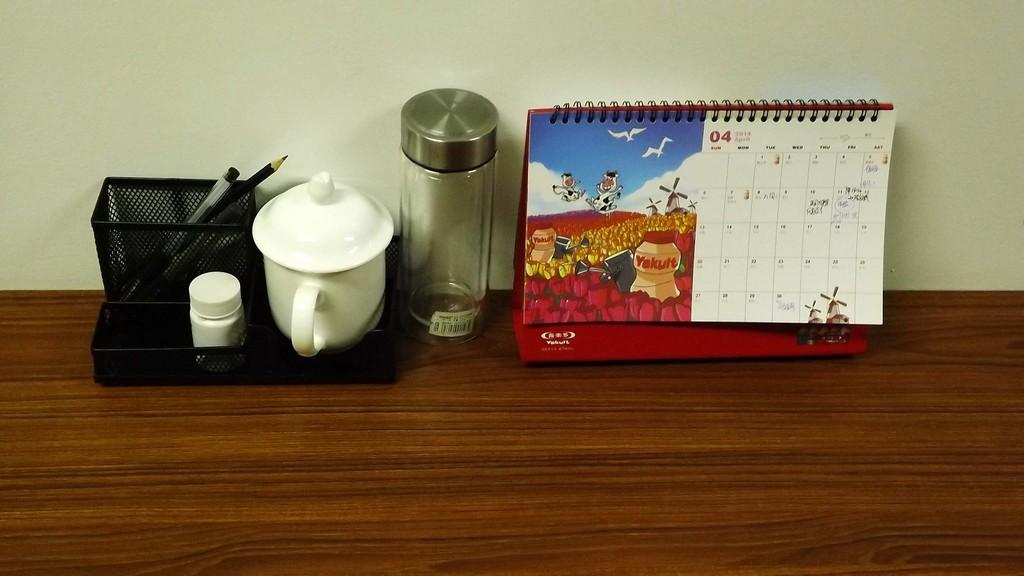What object is used for holding pens on the table? There is a pen holder on the table. What else can be seen on the table besides the pen holder? There is a bottle and a calendar on the table. Where is the throne located in the image? There is no throne present in the image. What type of offer is being made in the image? There is no offer being made in the image. 